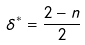Convert formula to latex. <formula><loc_0><loc_0><loc_500><loc_500>\delta ^ { * } = \frac { 2 - n } { 2 }</formula> 